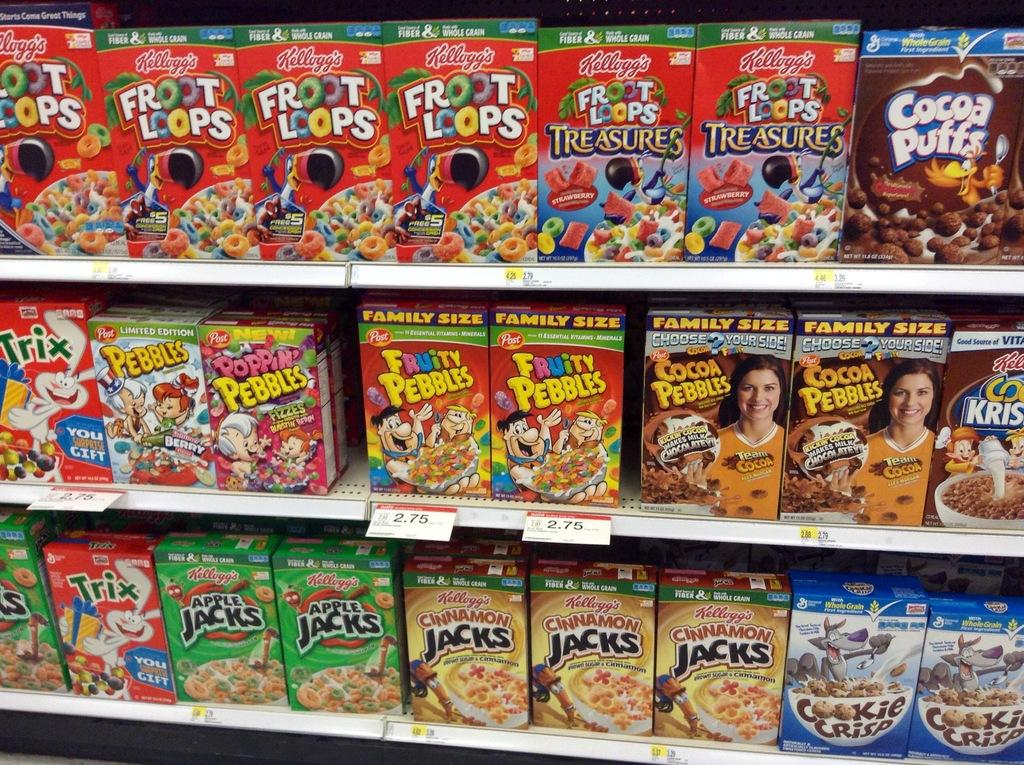Provide a one-sentence caption for the provided image. Kellogg,s Front Loops are displayed next to many other cereals. 